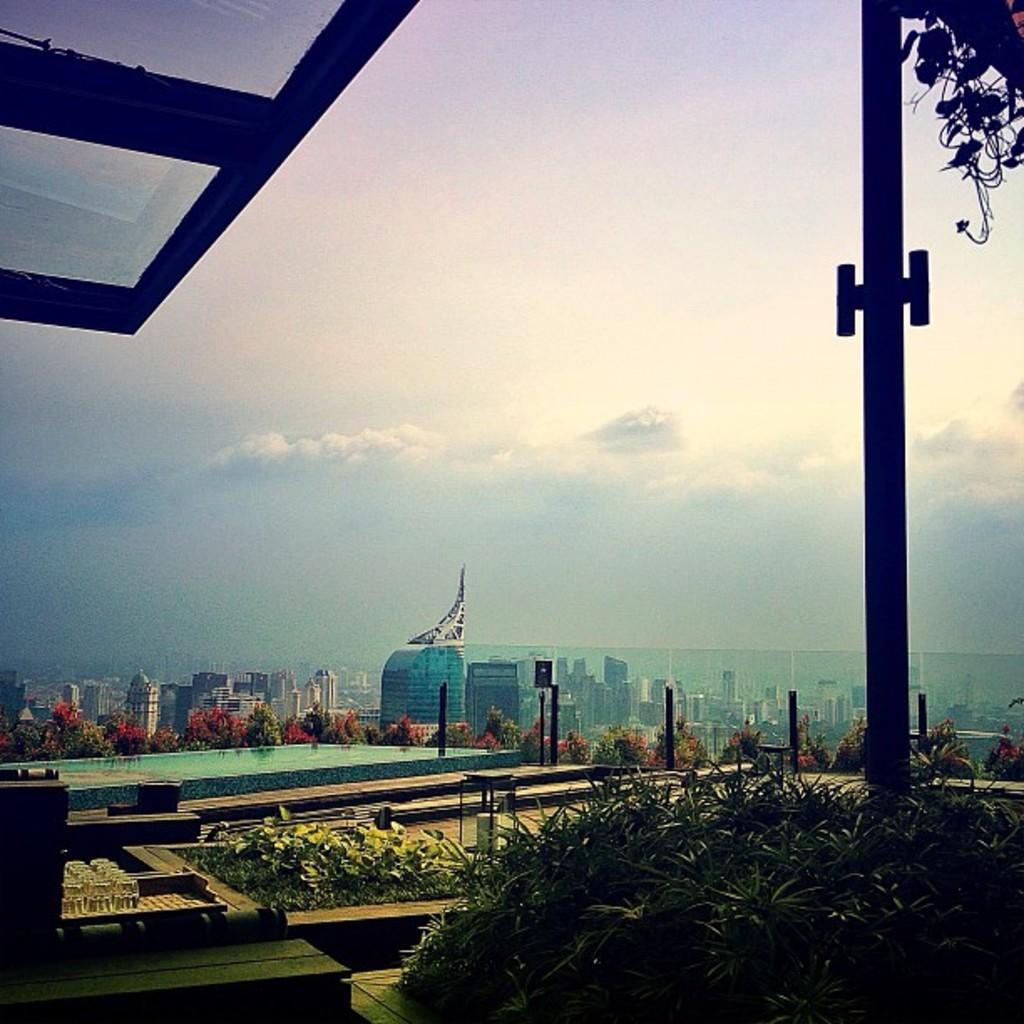Please provide a concise description of this image. In the foreground of this image, on the bottom, there are plants. On the right, there is a window and a plant on the top. On the left, there are glasses on a tray and a window on the top left corner. In the background, there are plants, a swimming pool and a glass railing and in the background, there are skyscrapers in the city, sky and the cloud. 